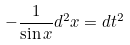<formula> <loc_0><loc_0><loc_500><loc_500>- \frac { 1 } { \sin x } d ^ { 2 } x = d t ^ { 2 }</formula> 